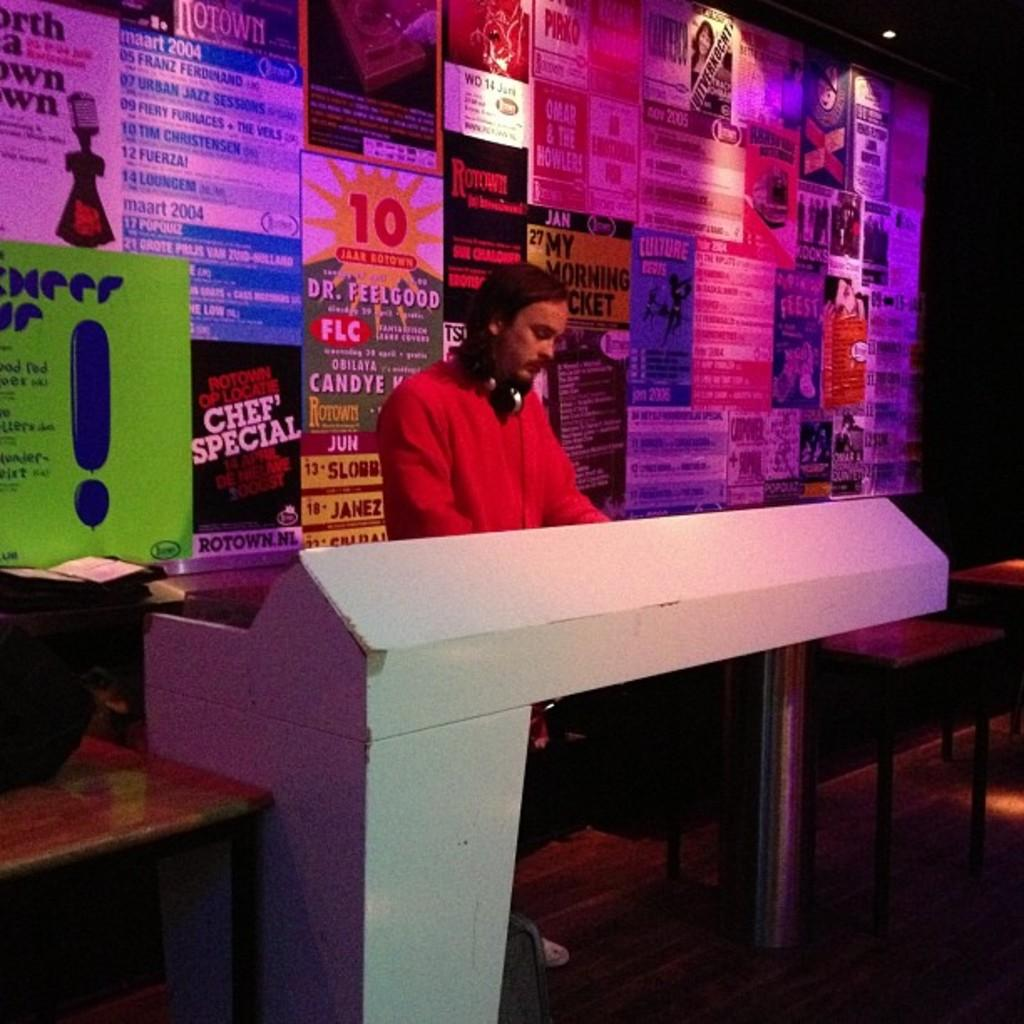<image>
Present a compact description of the photo's key features. A poster on the wall behind the man has the number 10 in red and advertises Dr. Feelgood. 